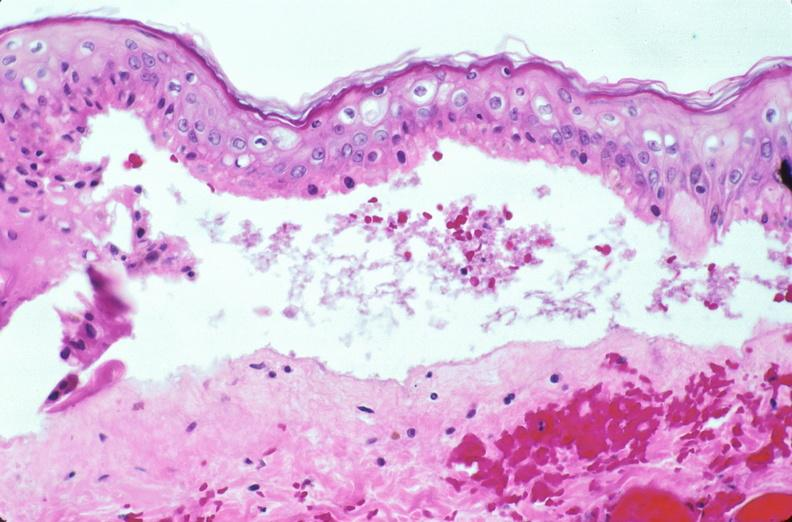where is this?
Answer the question using a single word or phrase. Skin 